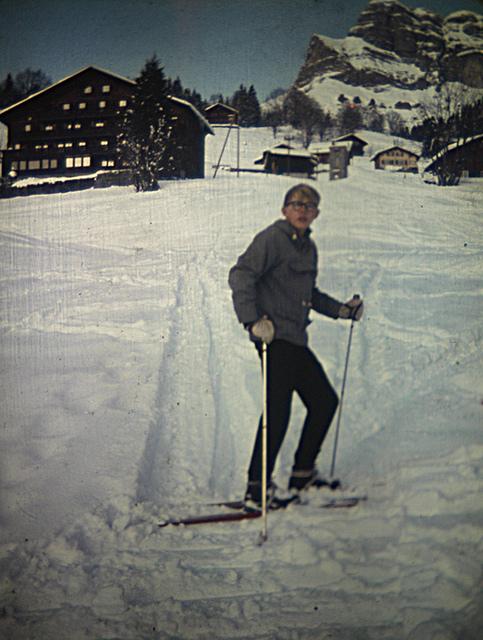What activity is the boy engaging in?
Concise answer only. Skiing. Is this boy thin?
Answer briefly. Yes. Is this photo from the past 10 years?
Give a very brief answer. No. What is the man looking at the camera using the ski polls for at the time the picture was taken?
Short answer required. Skiing. 